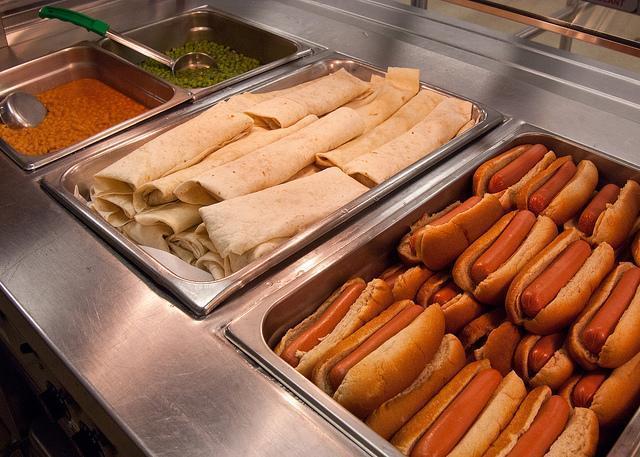How many toppings are there?
Give a very brief answer. 2. How many hot dogs are in the picture?
Give a very brief answer. 9. 